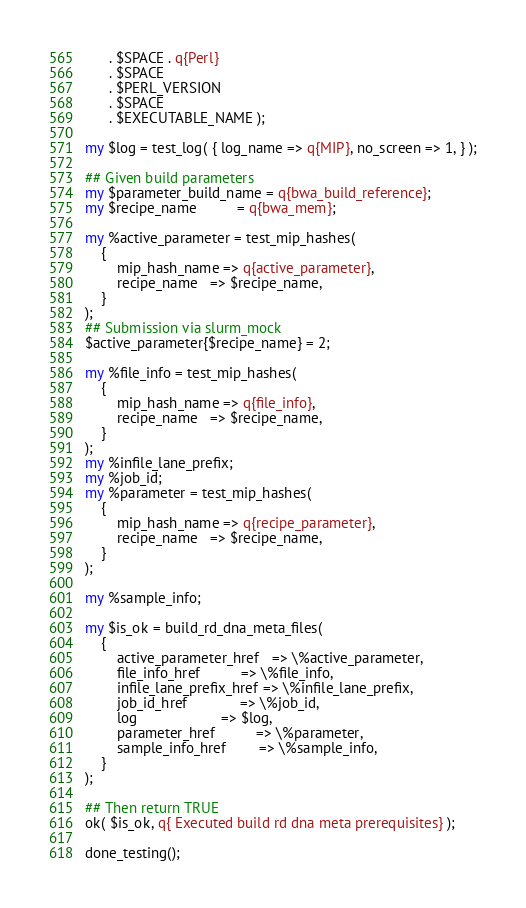<code> <loc_0><loc_0><loc_500><loc_500><_Perl_>      . $SPACE . q{Perl}
      . $SPACE
      . $PERL_VERSION
      . $SPACE
      . $EXECUTABLE_NAME );

my $log = test_log( { log_name => q{MIP}, no_screen => 1, } );

## Given build parameters
my $parameter_build_name = q{bwa_build_reference};
my $recipe_name          = q{bwa_mem};

my %active_parameter = test_mip_hashes(
    {
        mip_hash_name => q{active_parameter},
        recipe_name   => $recipe_name,
    }
);
## Submission via slurm_mock
$active_parameter{$recipe_name} = 2;

my %file_info = test_mip_hashes(
    {
        mip_hash_name => q{file_info},
        recipe_name   => $recipe_name,
    }
);
my %infile_lane_prefix;
my %job_id;
my %parameter = test_mip_hashes(
    {
        mip_hash_name => q{recipe_parameter},
        recipe_name   => $recipe_name,
    }
);

my %sample_info;

my $is_ok = build_rd_dna_meta_files(
    {
        active_parameter_href   => \%active_parameter,
        file_info_href          => \%file_info,
        infile_lane_prefix_href => \%infile_lane_prefix,
        job_id_href             => \%job_id,
        log                     => $log,
        parameter_href          => \%parameter,
        sample_info_href        => \%sample_info,
    }
);

## Then return TRUE
ok( $is_ok, q{ Executed build rd dna meta prerequisites} );

done_testing();
</code> 